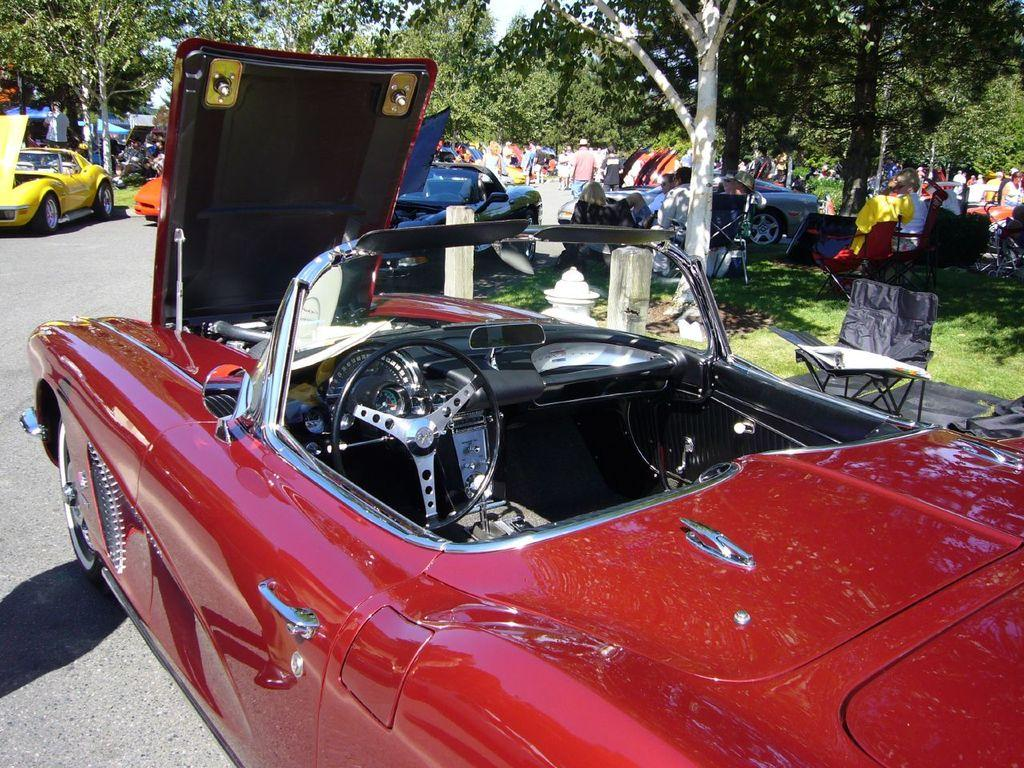What types of vehicles are present in the image? There are different colors of cars in the image. What can be seen in the background of the image? There is grass visible in the image, as well as trees. Are there any people present in the image? Yes, there are people in the image. What type of vegetable is being used as a balloon by the people in the image? There is no vegetable being used as a balloon in the image, nor are there any balloons present. 